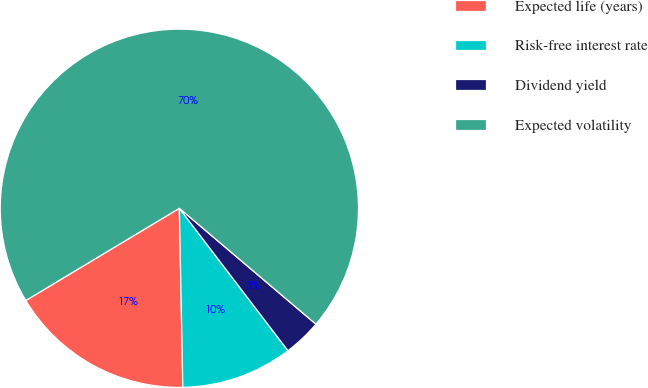<chart> <loc_0><loc_0><loc_500><loc_500><pie_chart><fcel>Expected life (years)<fcel>Risk-free interest rate<fcel>Dividend yield<fcel>Expected volatility<nl><fcel>16.7%<fcel>10.06%<fcel>3.43%<fcel>69.81%<nl></chart> 